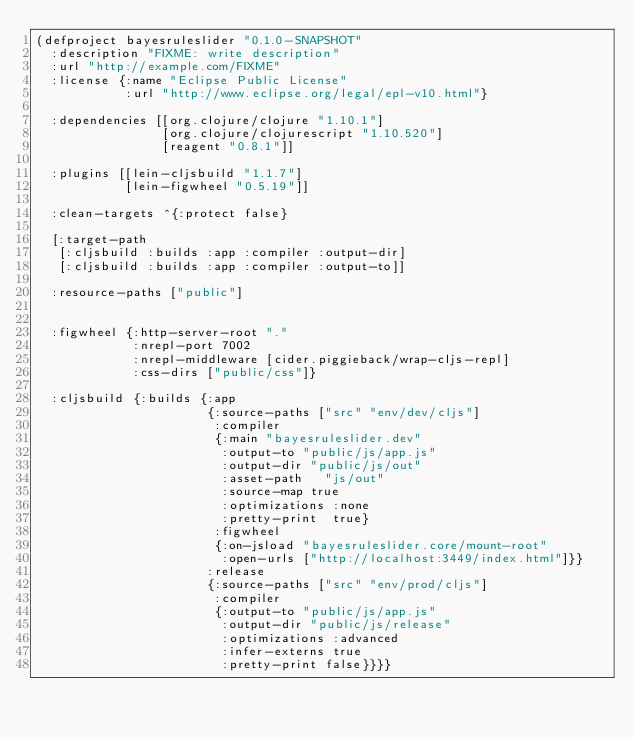<code> <loc_0><loc_0><loc_500><loc_500><_Clojure_>(defproject bayesruleslider "0.1.0-SNAPSHOT"
  :description "FIXME: write description"
  :url "http://example.com/FIXME"
  :license {:name "Eclipse Public License"
            :url "http://www.eclipse.org/legal/epl-v10.html"}

  :dependencies [[org.clojure/clojure "1.10.1"]
                 [org.clojure/clojurescript "1.10.520"]
                 [reagent "0.8.1"]]

  :plugins [[lein-cljsbuild "1.1.7"]
            [lein-figwheel "0.5.19"]]

  :clean-targets ^{:protect false}

  [:target-path
   [:cljsbuild :builds :app :compiler :output-dir]
   [:cljsbuild :builds :app :compiler :output-to]]

  :resource-paths ["public"]


  :figwheel {:http-server-root "."
             :nrepl-port 7002
             :nrepl-middleware [cider.piggieback/wrap-cljs-repl]
             :css-dirs ["public/css"]}

  :cljsbuild {:builds {:app
                       {:source-paths ["src" "env/dev/cljs"]
                        :compiler
                        {:main "bayesruleslider.dev"
                         :output-to "public/js/app.js"
                         :output-dir "public/js/out"
                         :asset-path   "js/out"
                         :source-map true
                         :optimizations :none
                         :pretty-print  true}
                        :figwheel
                        {:on-jsload "bayesruleslider.core/mount-root"
                         :open-urls ["http://localhost:3449/index.html"]}}
                       :release
                       {:source-paths ["src" "env/prod/cljs"]
                        :compiler
                        {:output-to "public/js/app.js"
                         :output-dir "public/js/release"
                         :optimizations :advanced
                         :infer-externs true
                         :pretty-print false}}}}
</code> 